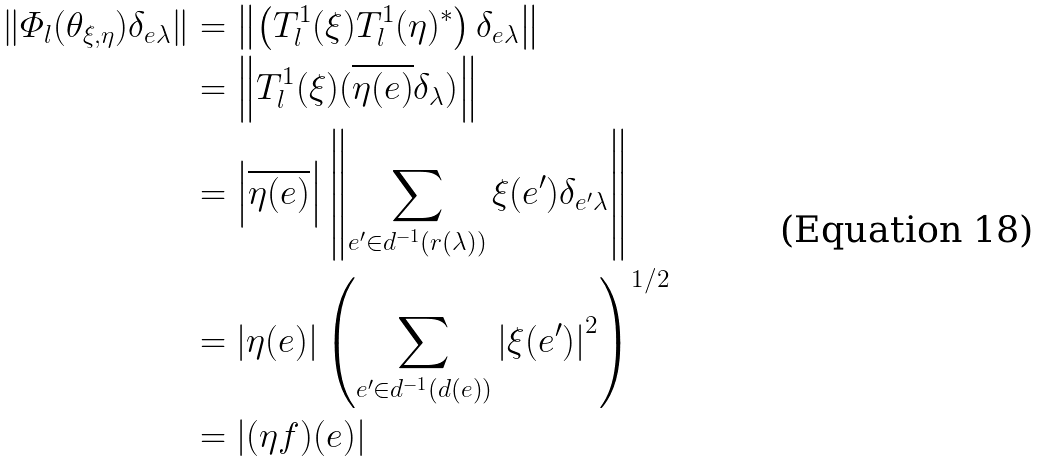Convert formula to latex. <formula><loc_0><loc_0><loc_500><loc_500>\left \| \varPhi _ { l } ( \theta _ { \xi , \eta } ) \delta _ { e \lambda } \right \| & = \left \| \left ( T _ { l } ^ { 1 } ( \xi ) T _ { l } ^ { 1 } ( \eta ) ^ { * } \right ) \delta _ { e \lambda } \right \| \\ & = \left \| T _ { l } ^ { 1 } ( \xi ) ( \overline { \eta ( e ) } \delta _ { \lambda } ) \right \| \\ & = \left | \overline { \eta ( e ) } \right | \left \| \sum _ { e ^ { \prime } \in d ^ { - 1 } ( r ( \lambda ) ) } \xi ( e ^ { \prime } ) \delta _ { e ^ { \prime } \lambda } \right \| \\ & = | \eta ( e ) | \left ( \sum _ { e ^ { \prime } \in d ^ { - 1 } ( d ( e ) ) } \left | \xi ( e ^ { \prime } ) \right | ^ { 2 } \right ) ^ { 1 / 2 } \\ & = \left | ( \eta f ) ( e ) \right |</formula> 